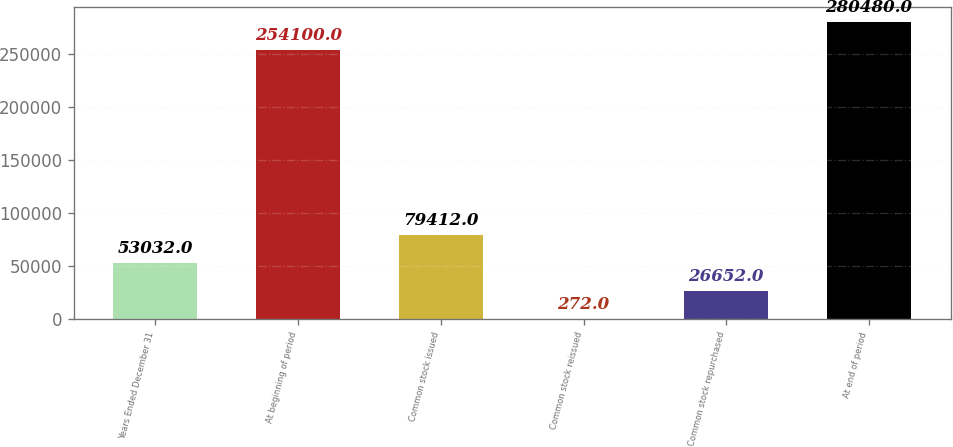Convert chart. <chart><loc_0><loc_0><loc_500><loc_500><bar_chart><fcel>Years Ended December 31<fcel>At beginning of period<fcel>Common stock issued<fcel>Common stock reissued<fcel>Common stock repurchased<fcel>At end of period<nl><fcel>53032<fcel>254100<fcel>79412<fcel>272<fcel>26652<fcel>280480<nl></chart> 